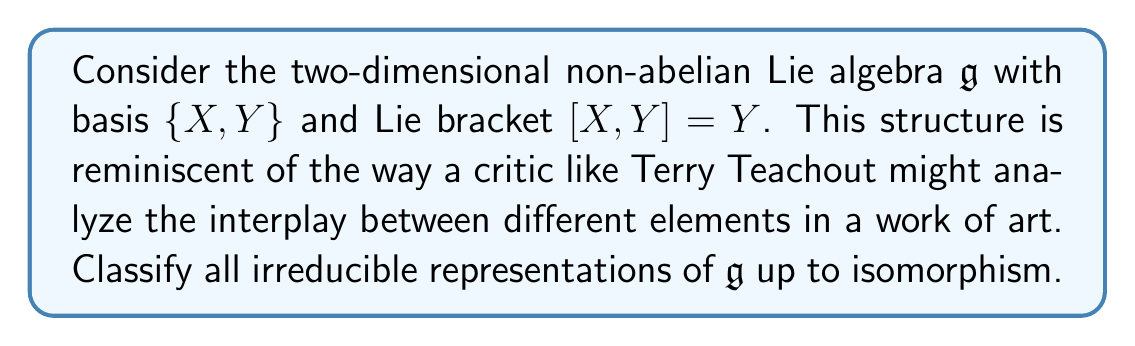Show me your answer to this math problem. To classify the irreducible representations of this Lie algebra, we'll follow these steps:

1) First, note that $\mathfrak{g}$ is solvable, as $[\mathfrak{g}, \mathfrak{g}] = \text{span}\{Y\}$ is one-dimensional.

2) By Lie's theorem, all irreducible representations of a solvable Lie algebra over an algebraically closed field of characteristic zero are one-dimensional.

3) Let $\rho: \mathfrak{g} \to \text{gl}(1, \mathbb{C}) \cong \mathbb{C}$ be an irreducible representation. We need to find all possible $\rho(X)$ and $\rho(Y)$ satisfying the Lie algebra homomorphism condition:

   $$\rho([X, Y]) = [\rho(X), \rho(Y)]$$

4) In this case, as the representation is one-dimensional, the right-hand side is always zero:

   $$[\rho(X), \rho(Y)] = \rho(X)\rho(Y) - \rho(Y)\rho(X) = 0$$

5) The left-hand side gives:

   $$\rho([X, Y]) = \rho(Y)$$

6) Equating these, we get $\rho(Y) = 0$.

7) For $\rho(X)$, we can choose any complex number $\lambda$.

8) Therefore, the irreducible representations are parameterized by $\lambda \in \mathbb{C}$, with:

   $$\rho_\lambda(X) = \lambda, \quad \rho_\lambda(Y) = 0$$

9) Two representations $\rho_\lambda$ and $\rho_{\lambda'}$ are isomorphic if and only if $\lambda = \lambda'$.

This classification is complete, as we've found all possible one-dimensional representations and shown that there are no higher-dimensional irreducible representations.
Answer: The irreducible representations of $\mathfrak{g}$ are all one-dimensional and are classified up to isomorphism by $\{\rho_\lambda : \lambda \in \mathbb{C}\}$, where $\rho_\lambda(X) = \lambda$ and $\rho_\lambda(Y) = 0$. 